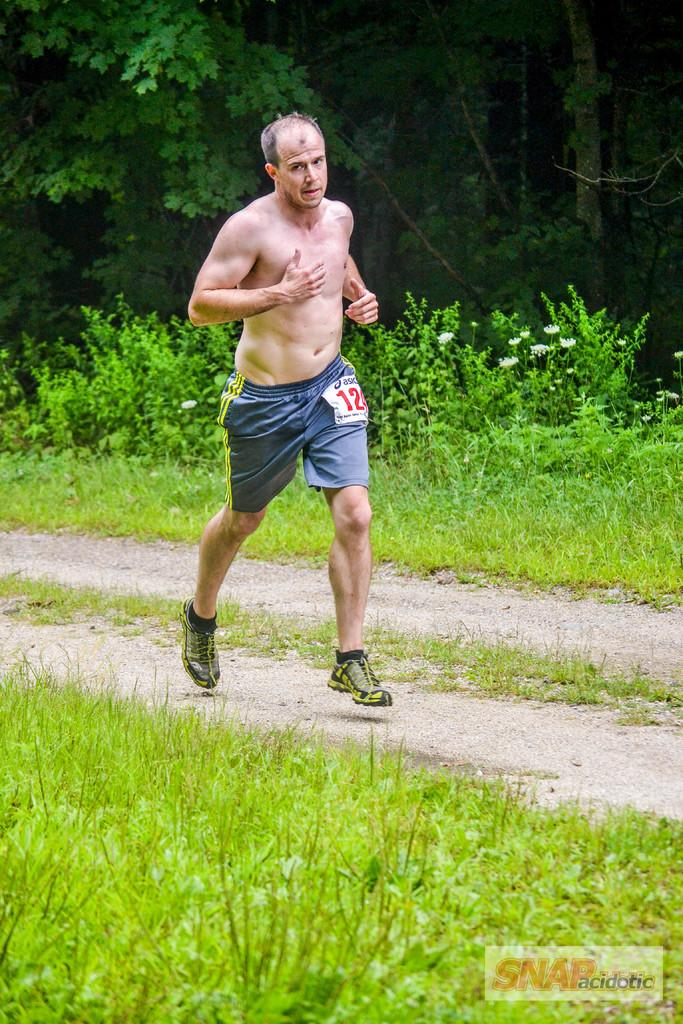Provide a one-sentence caption for the provided image. A bare chested name has number 12 on his shorts. 